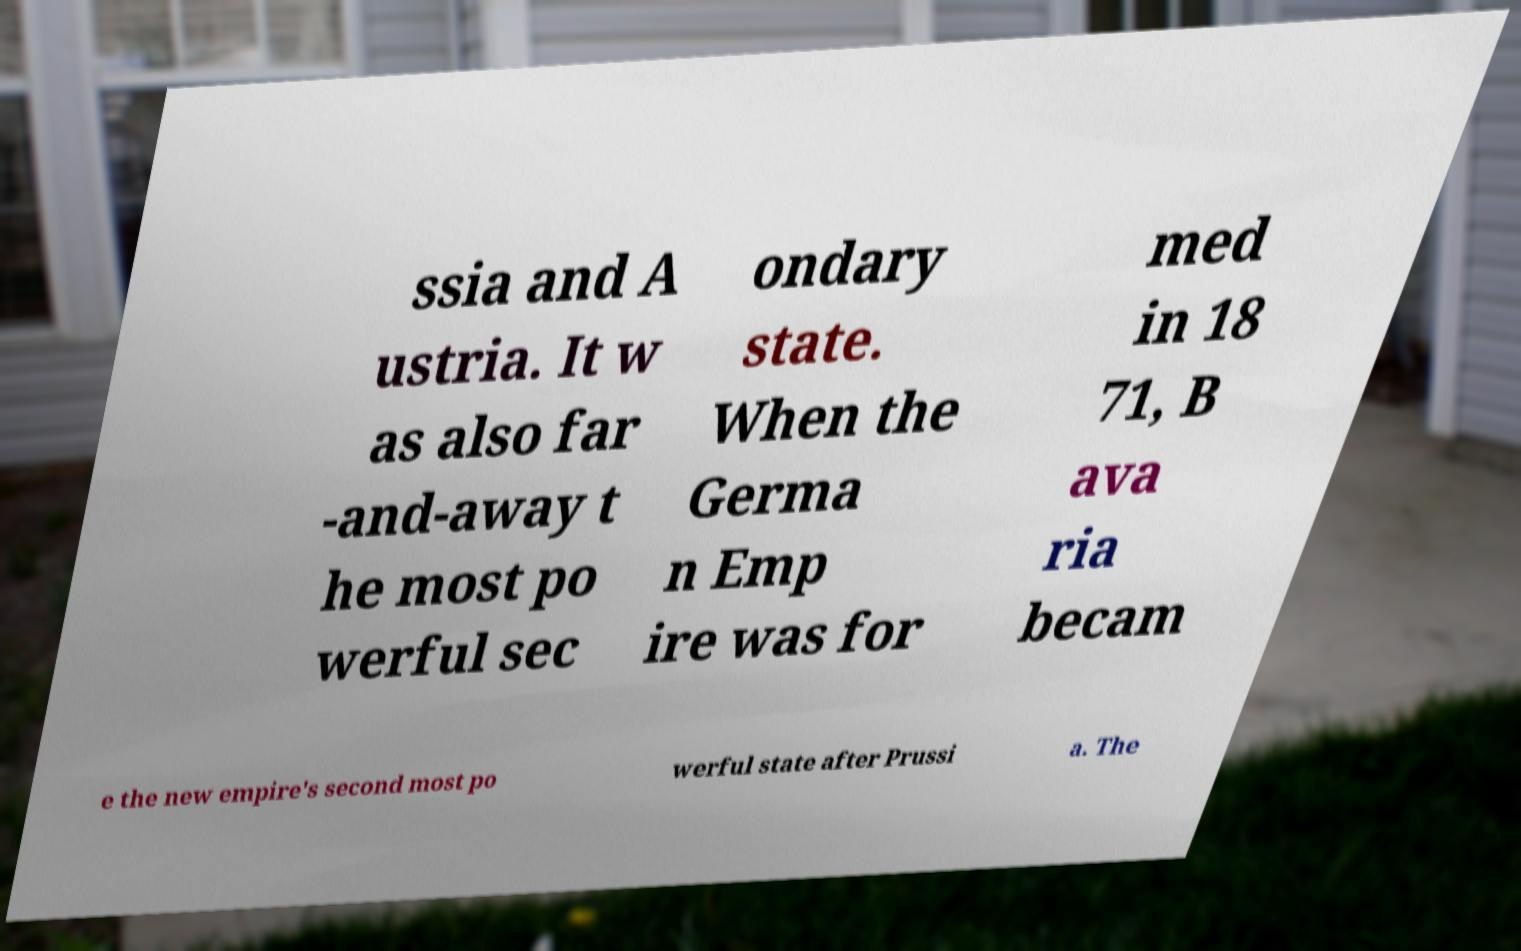Can you read and provide the text displayed in the image?This photo seems to have some interesting text. Can you extract and type it out for me? ssia and A ustria. It w as also far -and-away t he most po werful sec ondary state. When the Germa n Emp ire was for med in 18 71, B ava ria becam e the new empire's second most po werful state after Prussi a. The 